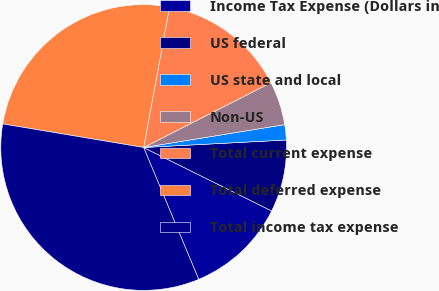Convert chart. <chart><loc_0><loc_0><loc_500><loc_500><pie_chart><fcel>Income Tax Expense (Dollars in<fcel>US federal<fcel>US state and local<fcel>Non-US<fcel>Total current expense<fcel>Total deferred expense<fcel>Total income tax expense<nl><fcel>11.38%<fcel>8.16%<fcel>1.72%<fcel>4.94%<fcel>14.6%<fcel>25.26%<fcel>33.93%<nl></chart> 